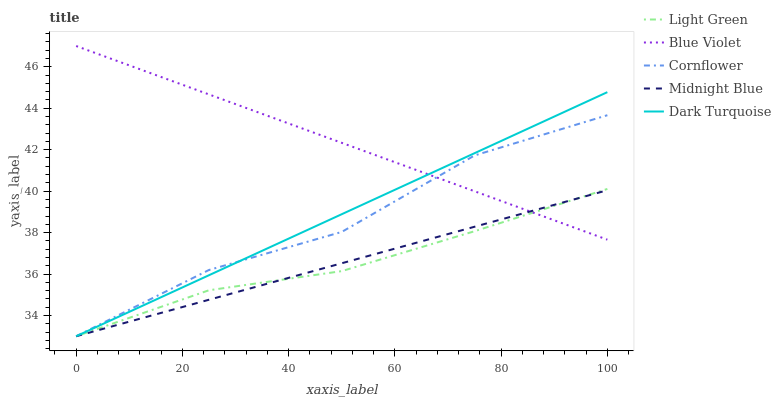Does Light Green have the minimum area under the curve?
Answer yes or no. Yes. Does Blue Violet have the maximum area under the curve?
Answer yes or no. Yes. Does Dark Turquoise have the minimum area under the curve?
Answer yes or no. No. Does Dark Turquoise have the maximum area under the curve?
Answer yes or no. No. Is Dark Turquoise the smoothest?
Answer yes or no. Yes. Is Cornflower the roughest?
Answer yes or no. Yes. Is Blue Violet the smoothest?
Answer yes or no. No. Is Blue Violet the roughest?
Answer yes or no. No. Does Cornflower have the lowest value?
Answer yes or no. Yes. Does Blue Violet have the lowest value?
Answer yes or no. No. Does Blue Violet have the highest value?
Answer yes or no. Yes. Does Dark Turquoise have the highest value?
Answer yes or no. No. Does Dark Turquoise intersect Cornflower?
Answer yes or no. Yes. Is Dark Turquoise less than Cornflower?
Answer yes or no. No. Is Dark Turquoise greater than Cornflower?
Answer yes or no. No. 